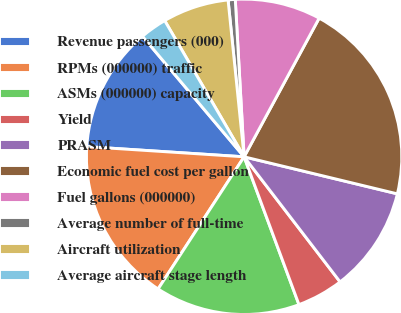Convert chart to OTSL. <chart><loc_0><loc_0><loc_500><loc_500><pie_chart><fcel>Revenue passengers (000)<fcel>RPMs (000000) traffic<fcel>ASMs (000000) capacity<fcel>Yield<fcel>PRASM<fcel>Economic fuel cost per gallon<fcel>Fuel gallons (000000)<fcel>Average number of full-time<fcel>Aircraft utilization<fcel>Average aircraft stage length<nl><fcel>12.82%<fcel>16.85%<fcel>14.84%<fcel>4.76%<fcel>10.81%<fcel>20.88%<fcel>8.79%<fcel>0.73%<fcel>6.78%<fcel>2.75%<nl></chart> 